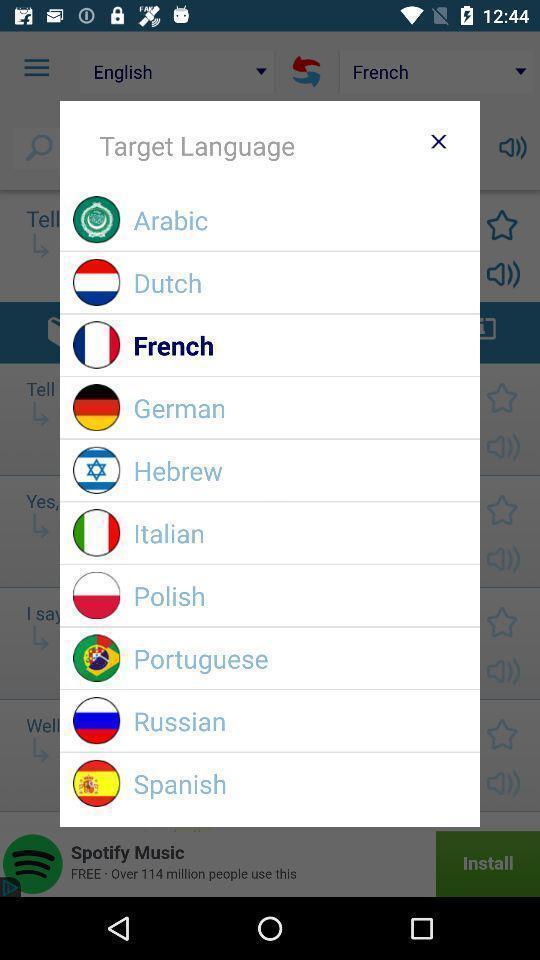Describe the visual elements of this screenshot. Pop-up to choose a language. 